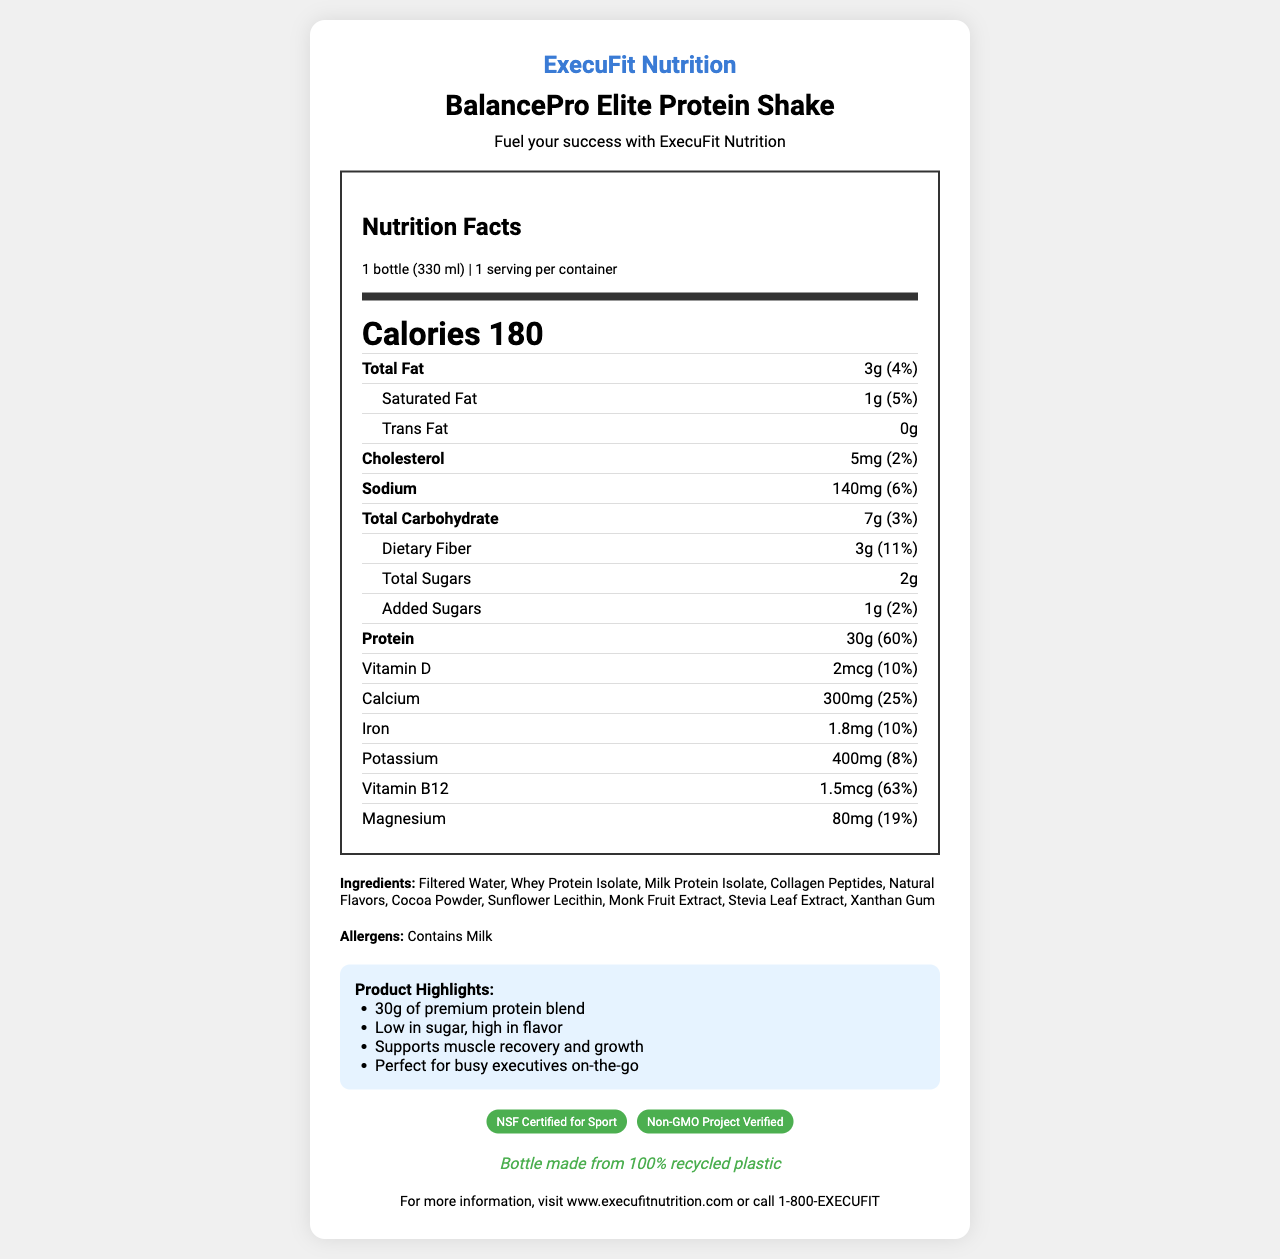what is the serving size? The serving size is stated under the "Nutrition Facts" section as "1 bottle (330 ml)".
Answer: 1 bottle (330 ml) who is the brand behind BalancePro Elite Protein Shake? The brand is mentioned at the top of the document in the header section: "ExecuFit Nutrition".
Answer: ExecuFit Nutrition how many servings per container are there? The servings per container is stated under the serving info as "1 serving per container".
Answer: 1 what is the calorie count of one serving? The calorie count for one serving is prominently displayed as "Calories 180".
Answer: 180 calories how much protein does the product provide per serving? The protein content per serving is listed in the nutrition facts as "Protein 30g".
Answer: 30g which of the following is a nutrient found in the BalancePro Elite Protein Shake? A. Vitamin C B. Vitamin E C. Vitamin D D. Vitamin K Among the nutrients listed, Vitamin D is mentioned with an amount of "2mcg" and a daily value of "10%".
Answer: C. Vitamin D what certifications does this product have? A. USDA Organic B. NSF Certified for Sport C. Non-GMO Project Verified D. Gluten-Free The product has two certifications listed in the document: "NSF Certified for Sport" and "Non-GMO Project Verified".
Answer: B. NSF Certified for Sport, C. Non-GMO Project Verified does BalancePro Elite Protein Shake contain any allergens? The document states in the allergens section: "Contains Milk".
Answer: Yes summarize the main highlights of BalancePro Elite Protein Shake. The product highlights section lists the key benefits and unique selling points of the BalancePro Elite Protein Shake.
Answer: The BalancePro Elite Protein Shake contains 30g of premium protein blend, is low in sugar and high in flavor, supports muscle recovery and growth, and is perfect for busy executives on-the-go. what is the amount of added sugars in the shake per serving? The amount of added sugars is listed under the nutrition facts as "Added Sugars 1g (2%)".
Answer: 1g is the information about the shelf life of the product available in the document? The document does not provide any details regarding the shelf life of the BalancePro Elite Protein Shake.
Answer: Not enough information 